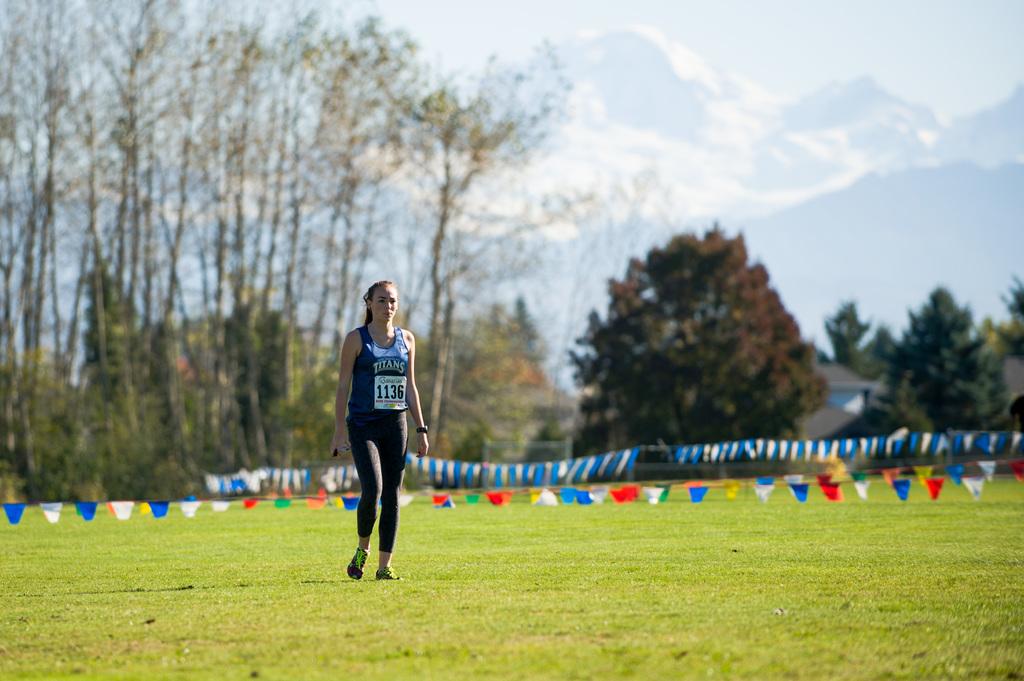What is the runners number?
Provide a succinct answer. 1136. What team name is on the girls shirt?
Provide a succinct answer. Titans. 